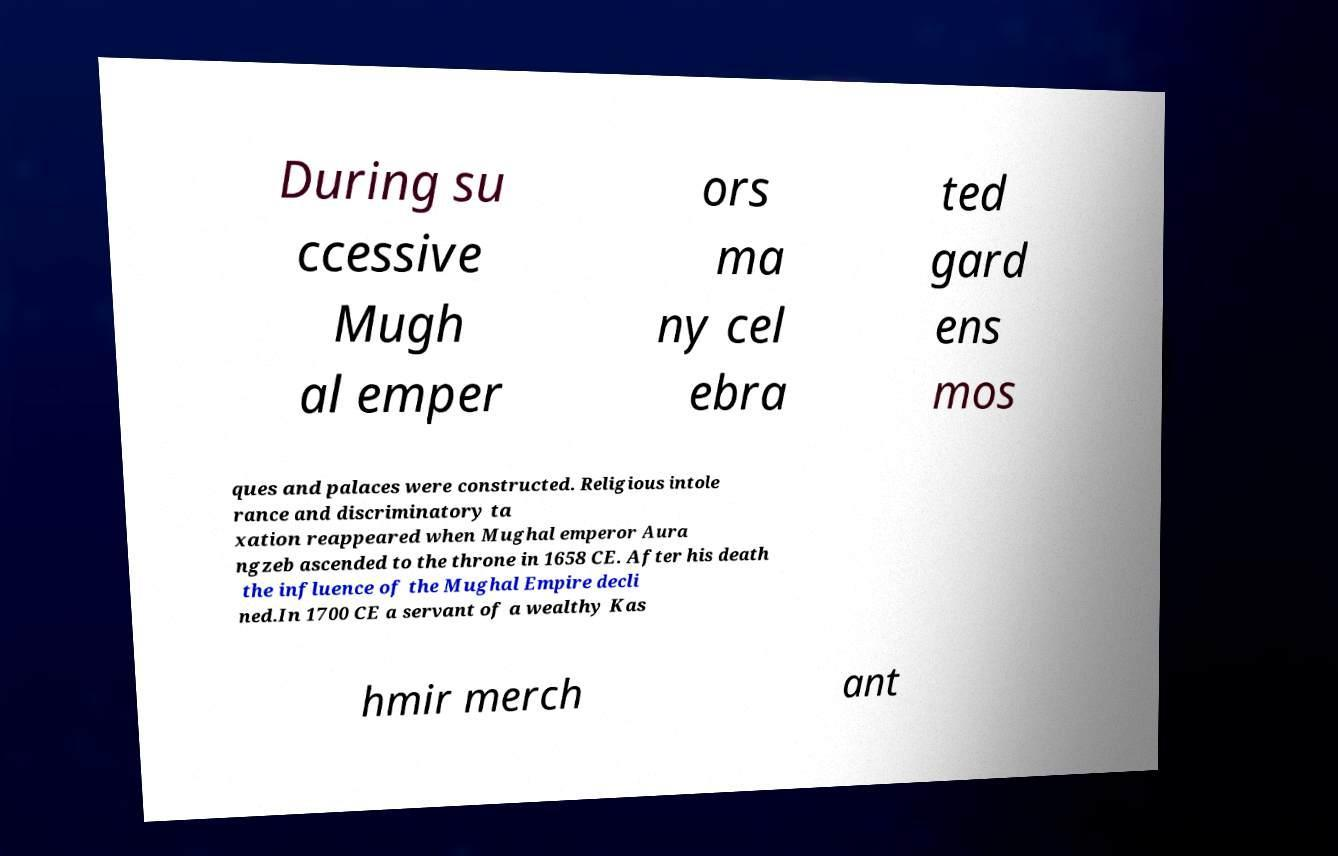I need the written content from this picture converted into text. Can you do that? During su ccessive Mugh al emper ors ma ny cel ebra ted gard ens mos ques and palaces were constructed. Religious intole rance and discriminatory ta xation reappeared when Mughal emperor Aura ngzeb ascended to the throne in 1658 CE. After his death the influence of the Mughal Empire decli ned.In 1700 CE a servant of a wealthy Kas hmir merch ant 